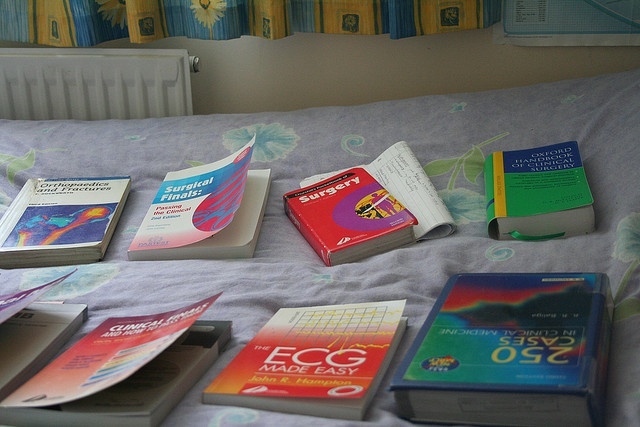Describe the objects in this image and their specific colors. I can see bed in teal, gray, darkgray, and black tones, book in teal, black, navy, and gray tones, book in teal, black, gray, salmon, and darkgray tones, book in teal, gray, brown, and darkgray tones, and book in teal, gray, lightgray, and darkgray tones in this image. 